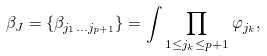<formula> <loc_0><loc_0><loc_500><loc_500>\beta _ { J } = \{ \beta _ { j _ { 1 } \dots j _ { p + 1 } } \} = \int \prod _ { 1 \leq j _ { k } \leq p + 1 } \varphi _ { j _ { k } } ,</formula> 